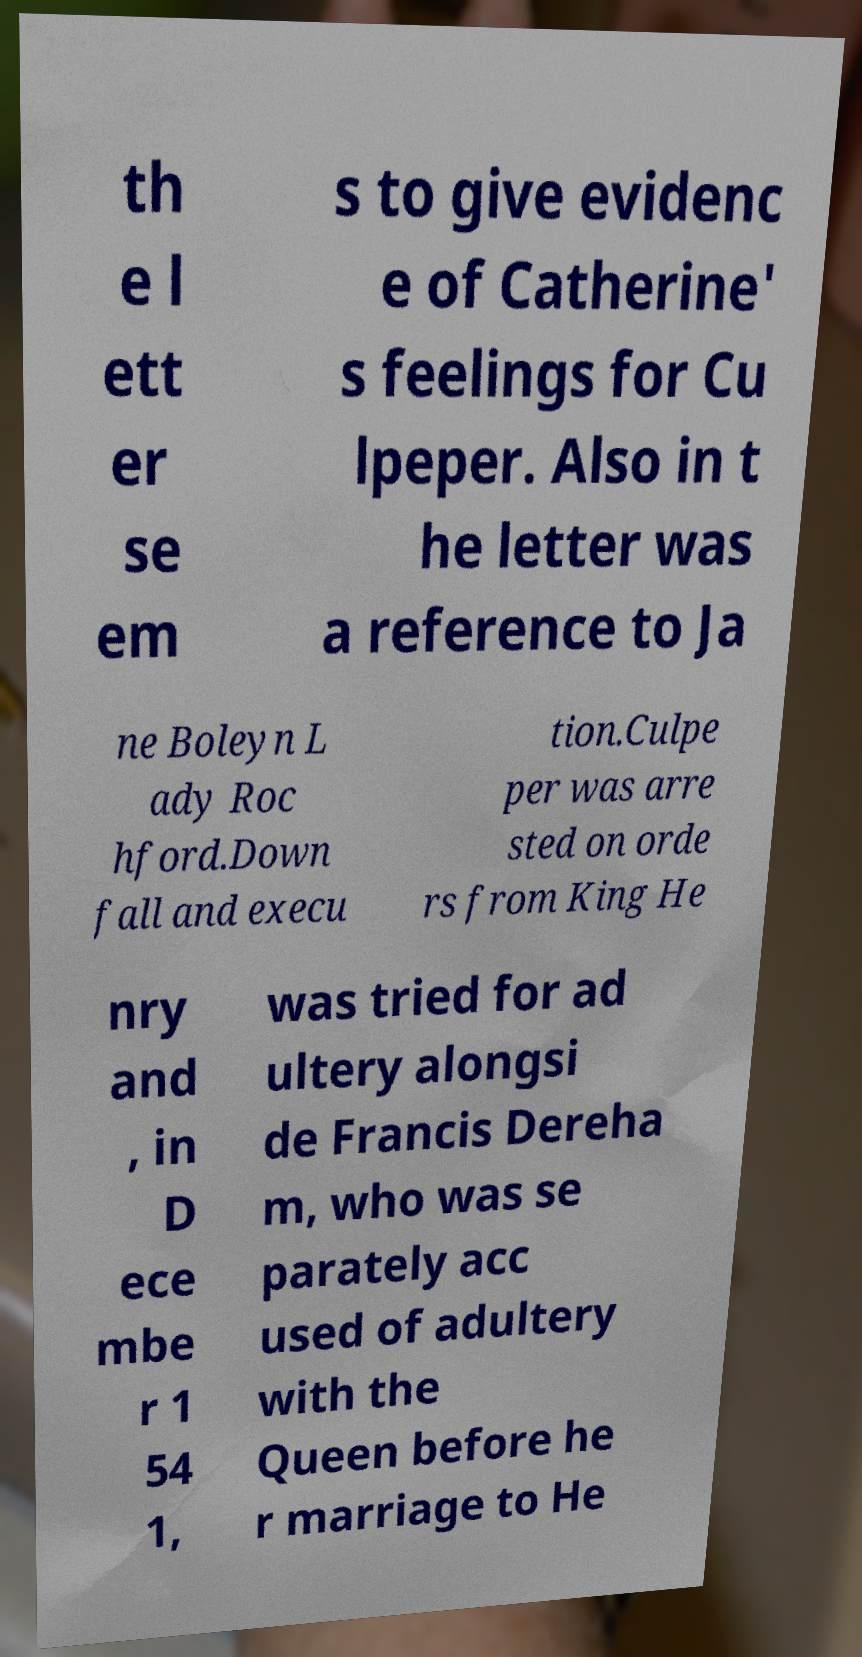Can you read and provide the text displayed in the image?This photo seems to have some interesting text. Can you extract and type it out for me? th e l ett er se em s to give evidenc e of Catherine' s feelings for Cu lpeper. Also in t he letter was a reference to Ja ne Boleyn L ady Roc hford.Down fall and execu tion.Culpe per was arre sted on orde rs from King He nry and , in D ece mbe r 1 54 1, was tried for ad ultery alongsi de Francis Dereha m, who was se parately acc used of adultery with the Queen before he r marriage to He 